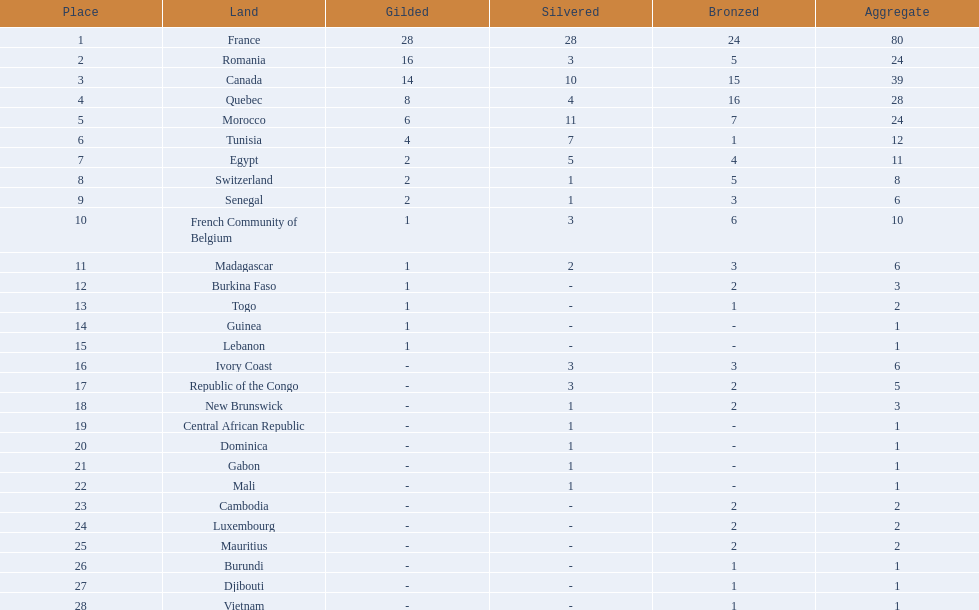What is the total number of bronze medals that togo has won? 1. 